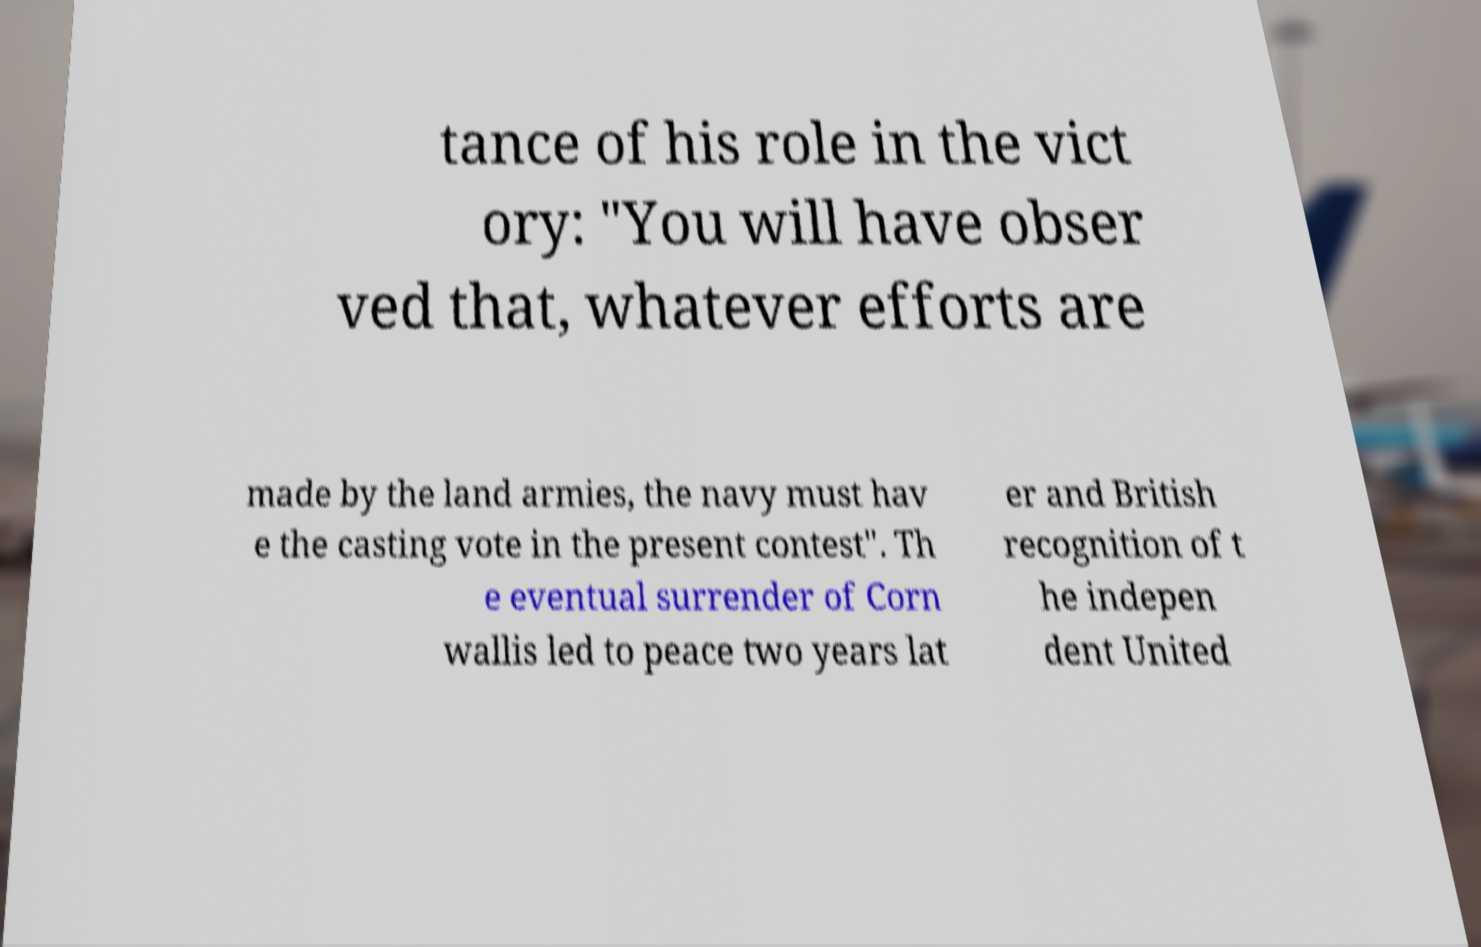Can you read and provide the text displayed in the image?This photo seems to have some interesting text. Can you extract and type it out for me? tance of his role in the vict ory: "You will have obser ved that, whatever efforts are made by the land armies, the navy must hav e the casting vote in the present contest". Th e eventual surrender of Corn wallis led to peace two years lat er and British recognition of t he indepen dent United 